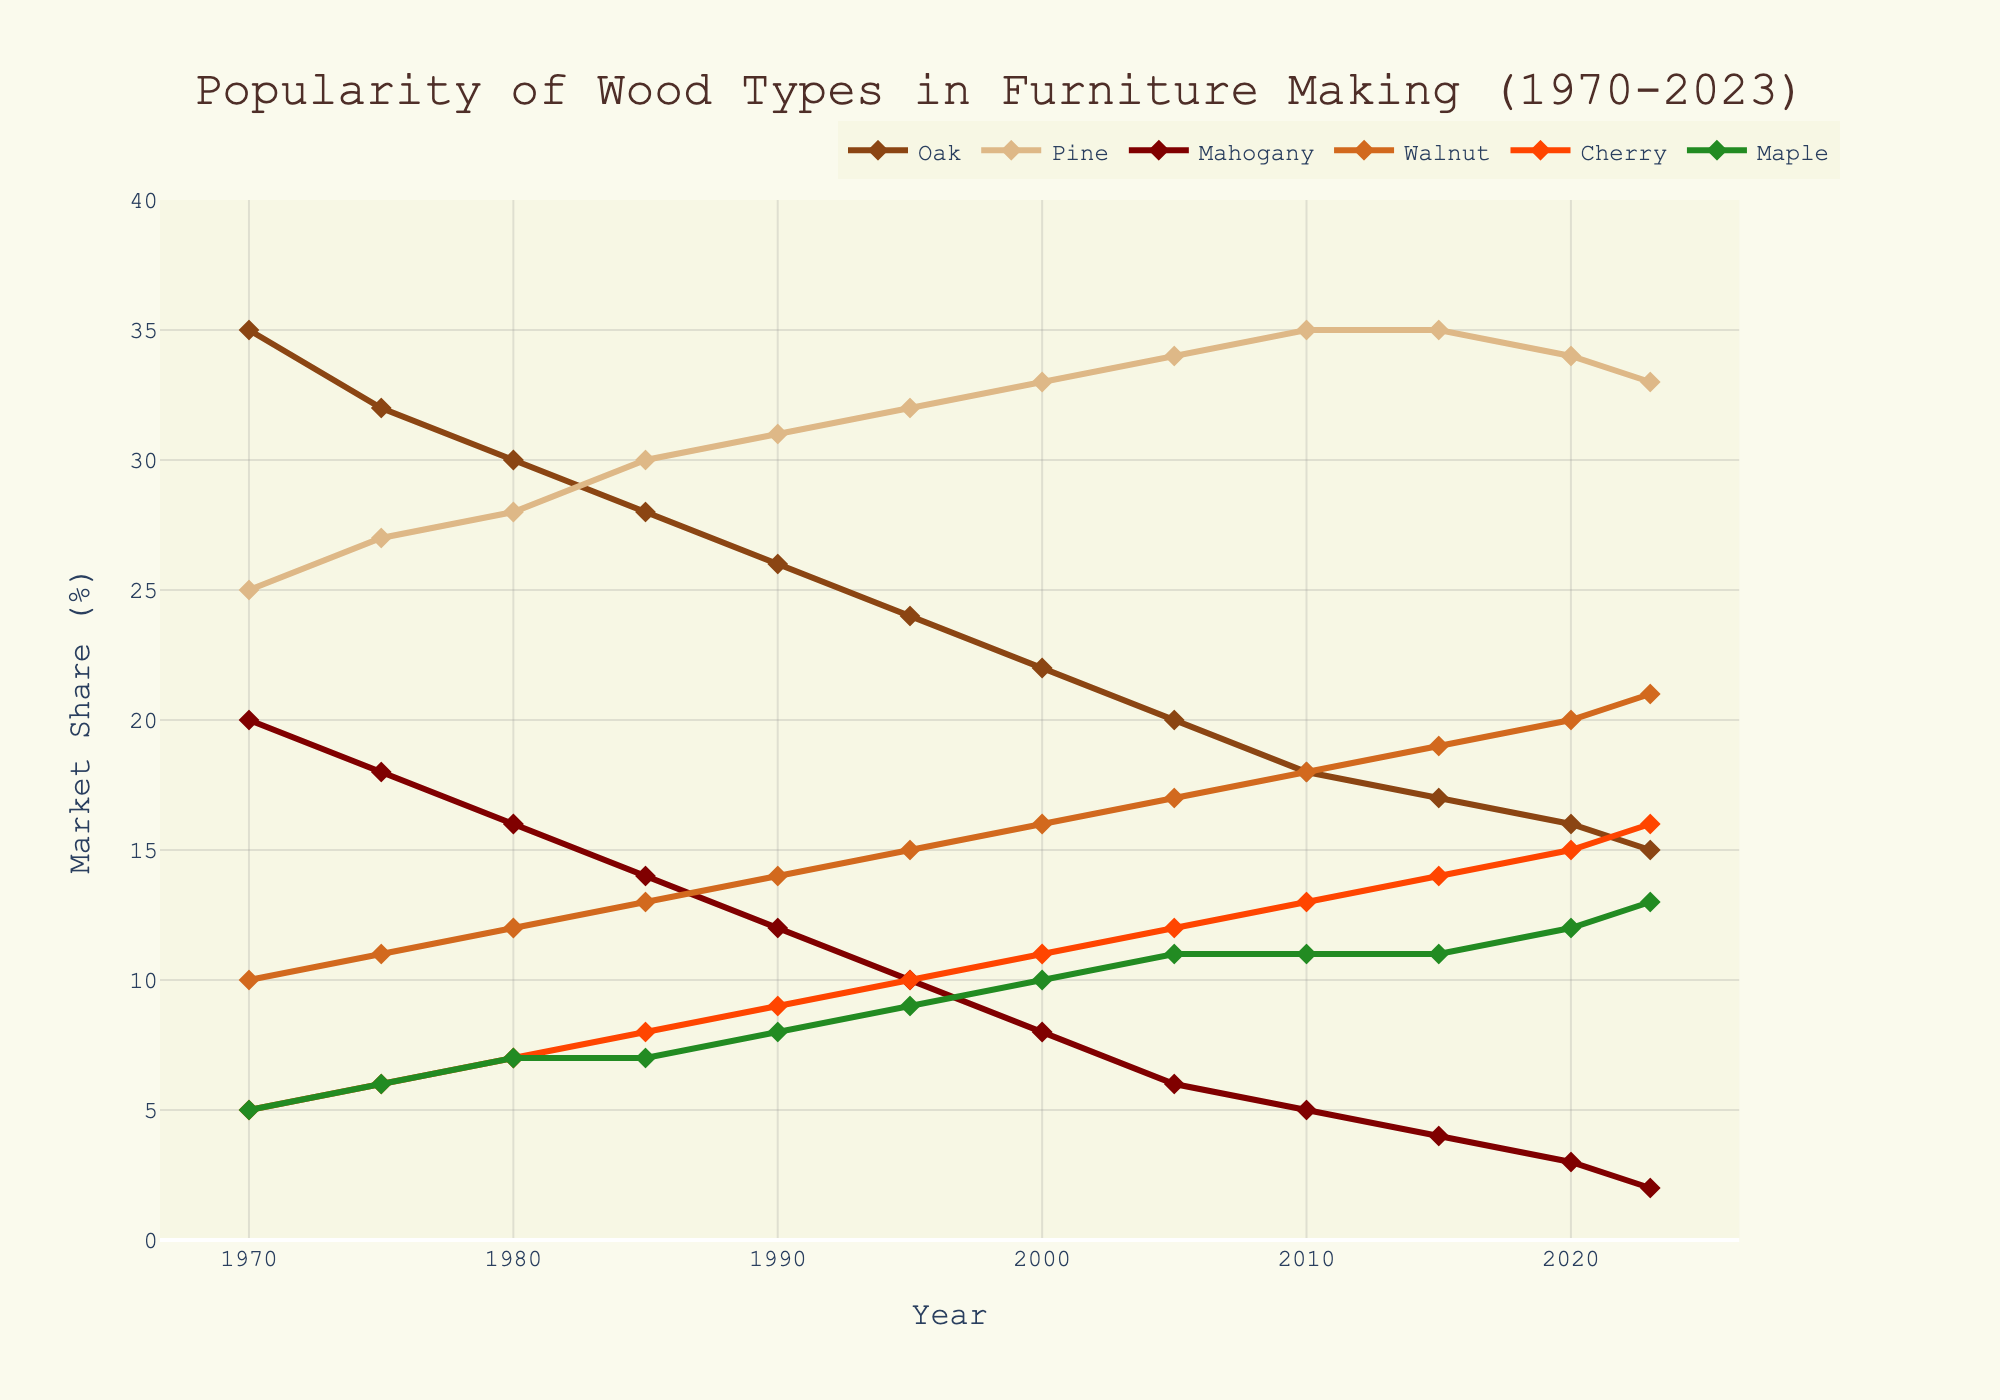What's the trend of Oak's popularity from 1970 to 2023? From 1970 to 2023, Oak's market share consistently decreases. Initially, Oak had the highest market share at 35%, but this percentage steadily drops over the years, ending at 15% in 2023.
Answer: Decreasing Which wood type had the highest market share in 2005? In 2005, Pine held the highest market share among the wood types, reaching 34%. This is identified by observing the year 2005 and noting the highest value among the wood types.
Answer: Pine What was the difference in market share between Cherry and Mahogany in 2023? In 2023, Cherry had a market share of 16%, and Mahogany had a market share of 2%. The difference can be calculated by subtracting the market share of Mahogany from Cherry (16% - 2% = 14%).
Answer: 14% How did Maple's market share change between 1990 and 2023? Maple's market share in 1990 was 8%, and by 2023, it had increased to 13%. We observe an overall increase in Maple's market share, which can be computed as (13% - 8% = 5%).
Answer: Increased by 5% What is the average market share of Walnut from 1970 to 2023? To find the average market share of Walnut, sum all the values from 1970 to 2023 and divide by the number of years. (10 + 11 + 12 + 13 + 14 + 15 + 16 + 17 + 18 + 19 + 20 + 21) / 12 = 15.5%.
Answer: 15.5% Which wood type saw the least change in market share over the period 1970 to 2023? Cherry started with a market share of 5% in 1970 and ended with 16% in 2023. Consequently, it had the smallest rate of change in percentage values as compared to other wood types that exhibit larger differing trends over the years.
Answer: Cherry In what year did Pine's market share surpass Oak's market share? In 1980, Pine had a market share of 28%, while Oak had 30%. However, by 1985, Pine's market share increased to 30% while Oak's decreased to 28%. Thus, 1985 marks the year when Pine overtook Oak's market share.
Answer: 1985 Which two wood types remained closest in market share throughout the period? Pine and Oak started with significant differences but equalized and maintained proximity in their percentages from 1975 onwards, except for the first few years. Pine overtakes and consistently stays above Oak afterwards, demonstrating their closeness in trend.
Answer: Pine and Oak 